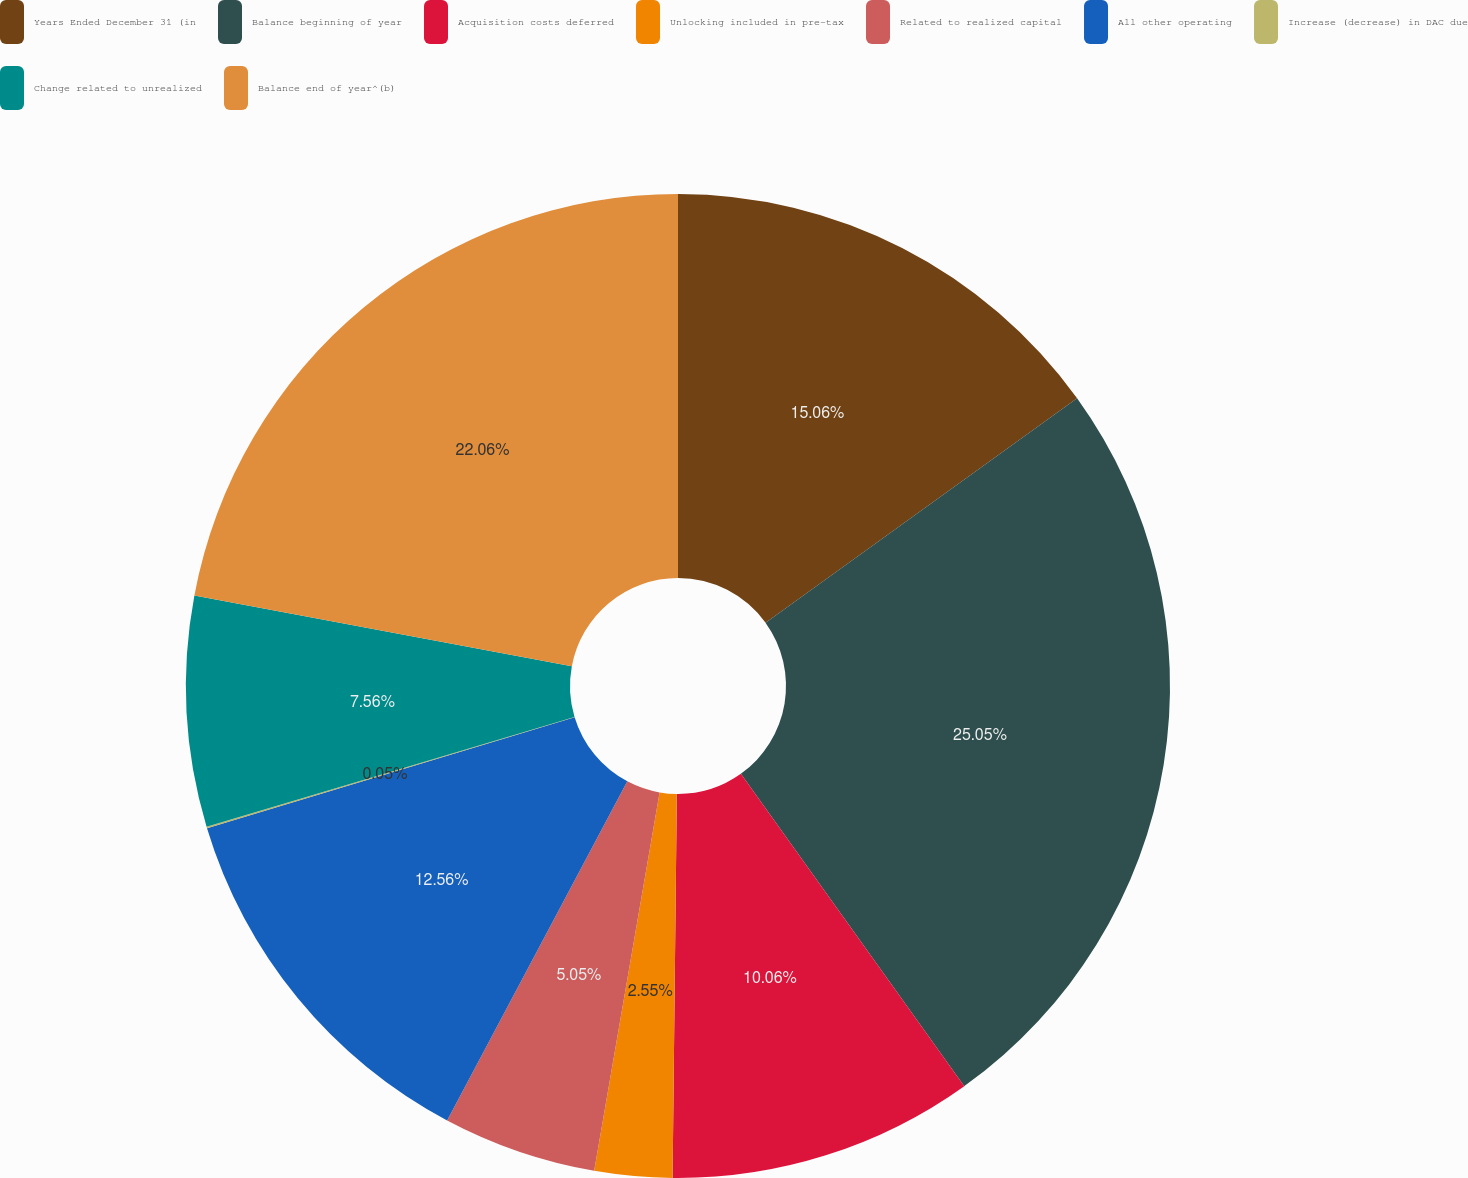<chart> <loc_0><loc_0><loc_500><loc_500><pie_chart><fcel>Years Ended December 31 (in<fcel>Balance beginning of year<fcel>Acquisition costs deferred<fcel>Unlocking included in pre-tax<fcel>Related to realized capital<fcel>All other operating<fcel>Increase (decrease) in DAC due<fcel>Change related to unrealized<fcel>Balance end of year^(b)<nl><fcel>15.06%<fcel>25.06%<fcel>10.06%<fcel>2.55%<fcel>5.05%<fcel>12.56%<fcel>0.05%<fcel>7.56%<fcel>22.06%<nl></chart> 